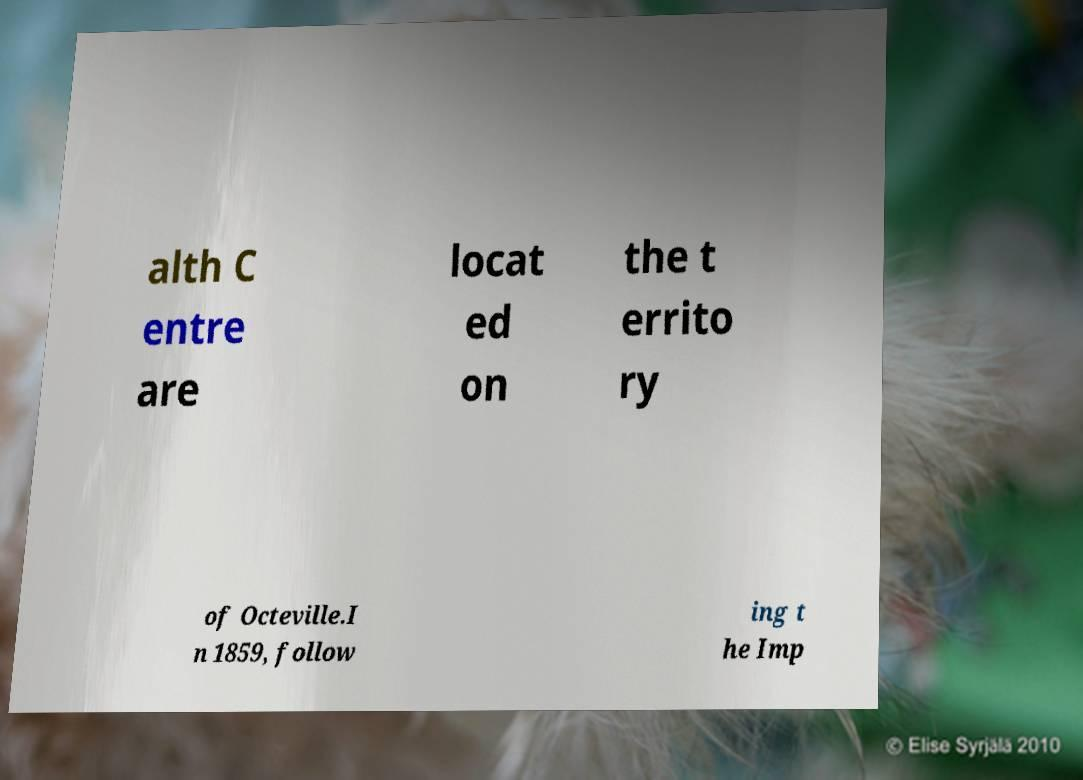For documentation purposes, I need the text within this image transcribed. Could you provide that? alth C entre are locat ed on the t errito ry of Octeville.I n 1859, follow ing t he Imp 